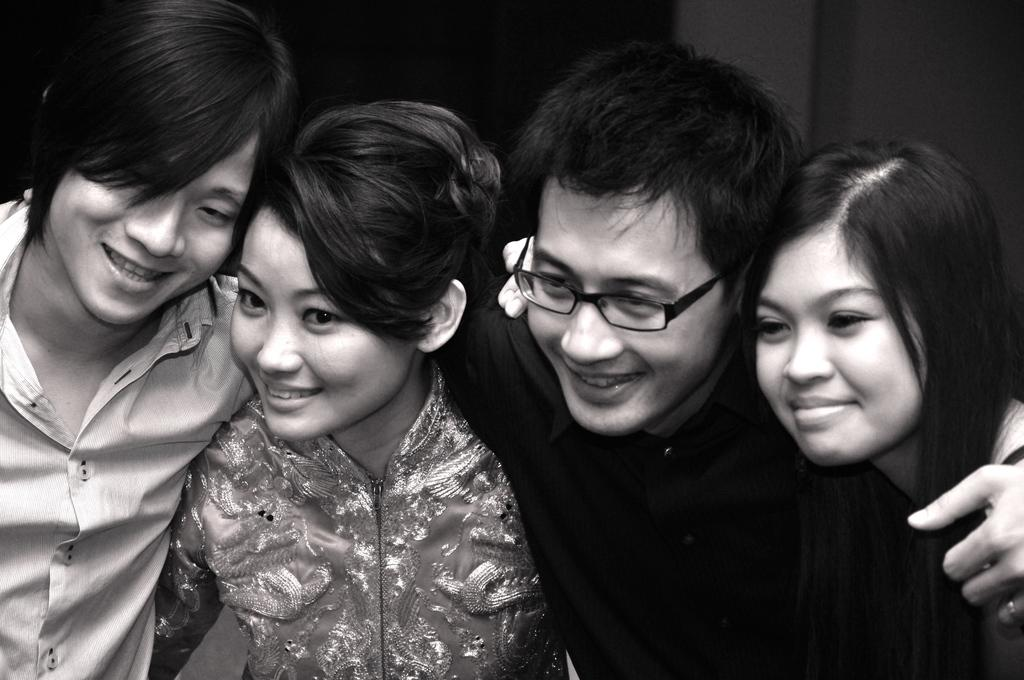What is the color scheme of the image? The image is black and white. What types of people are present in the image? There are both men and women in the image. What type of frame is around the letter in the image? There is no letter or frame present in the image. 